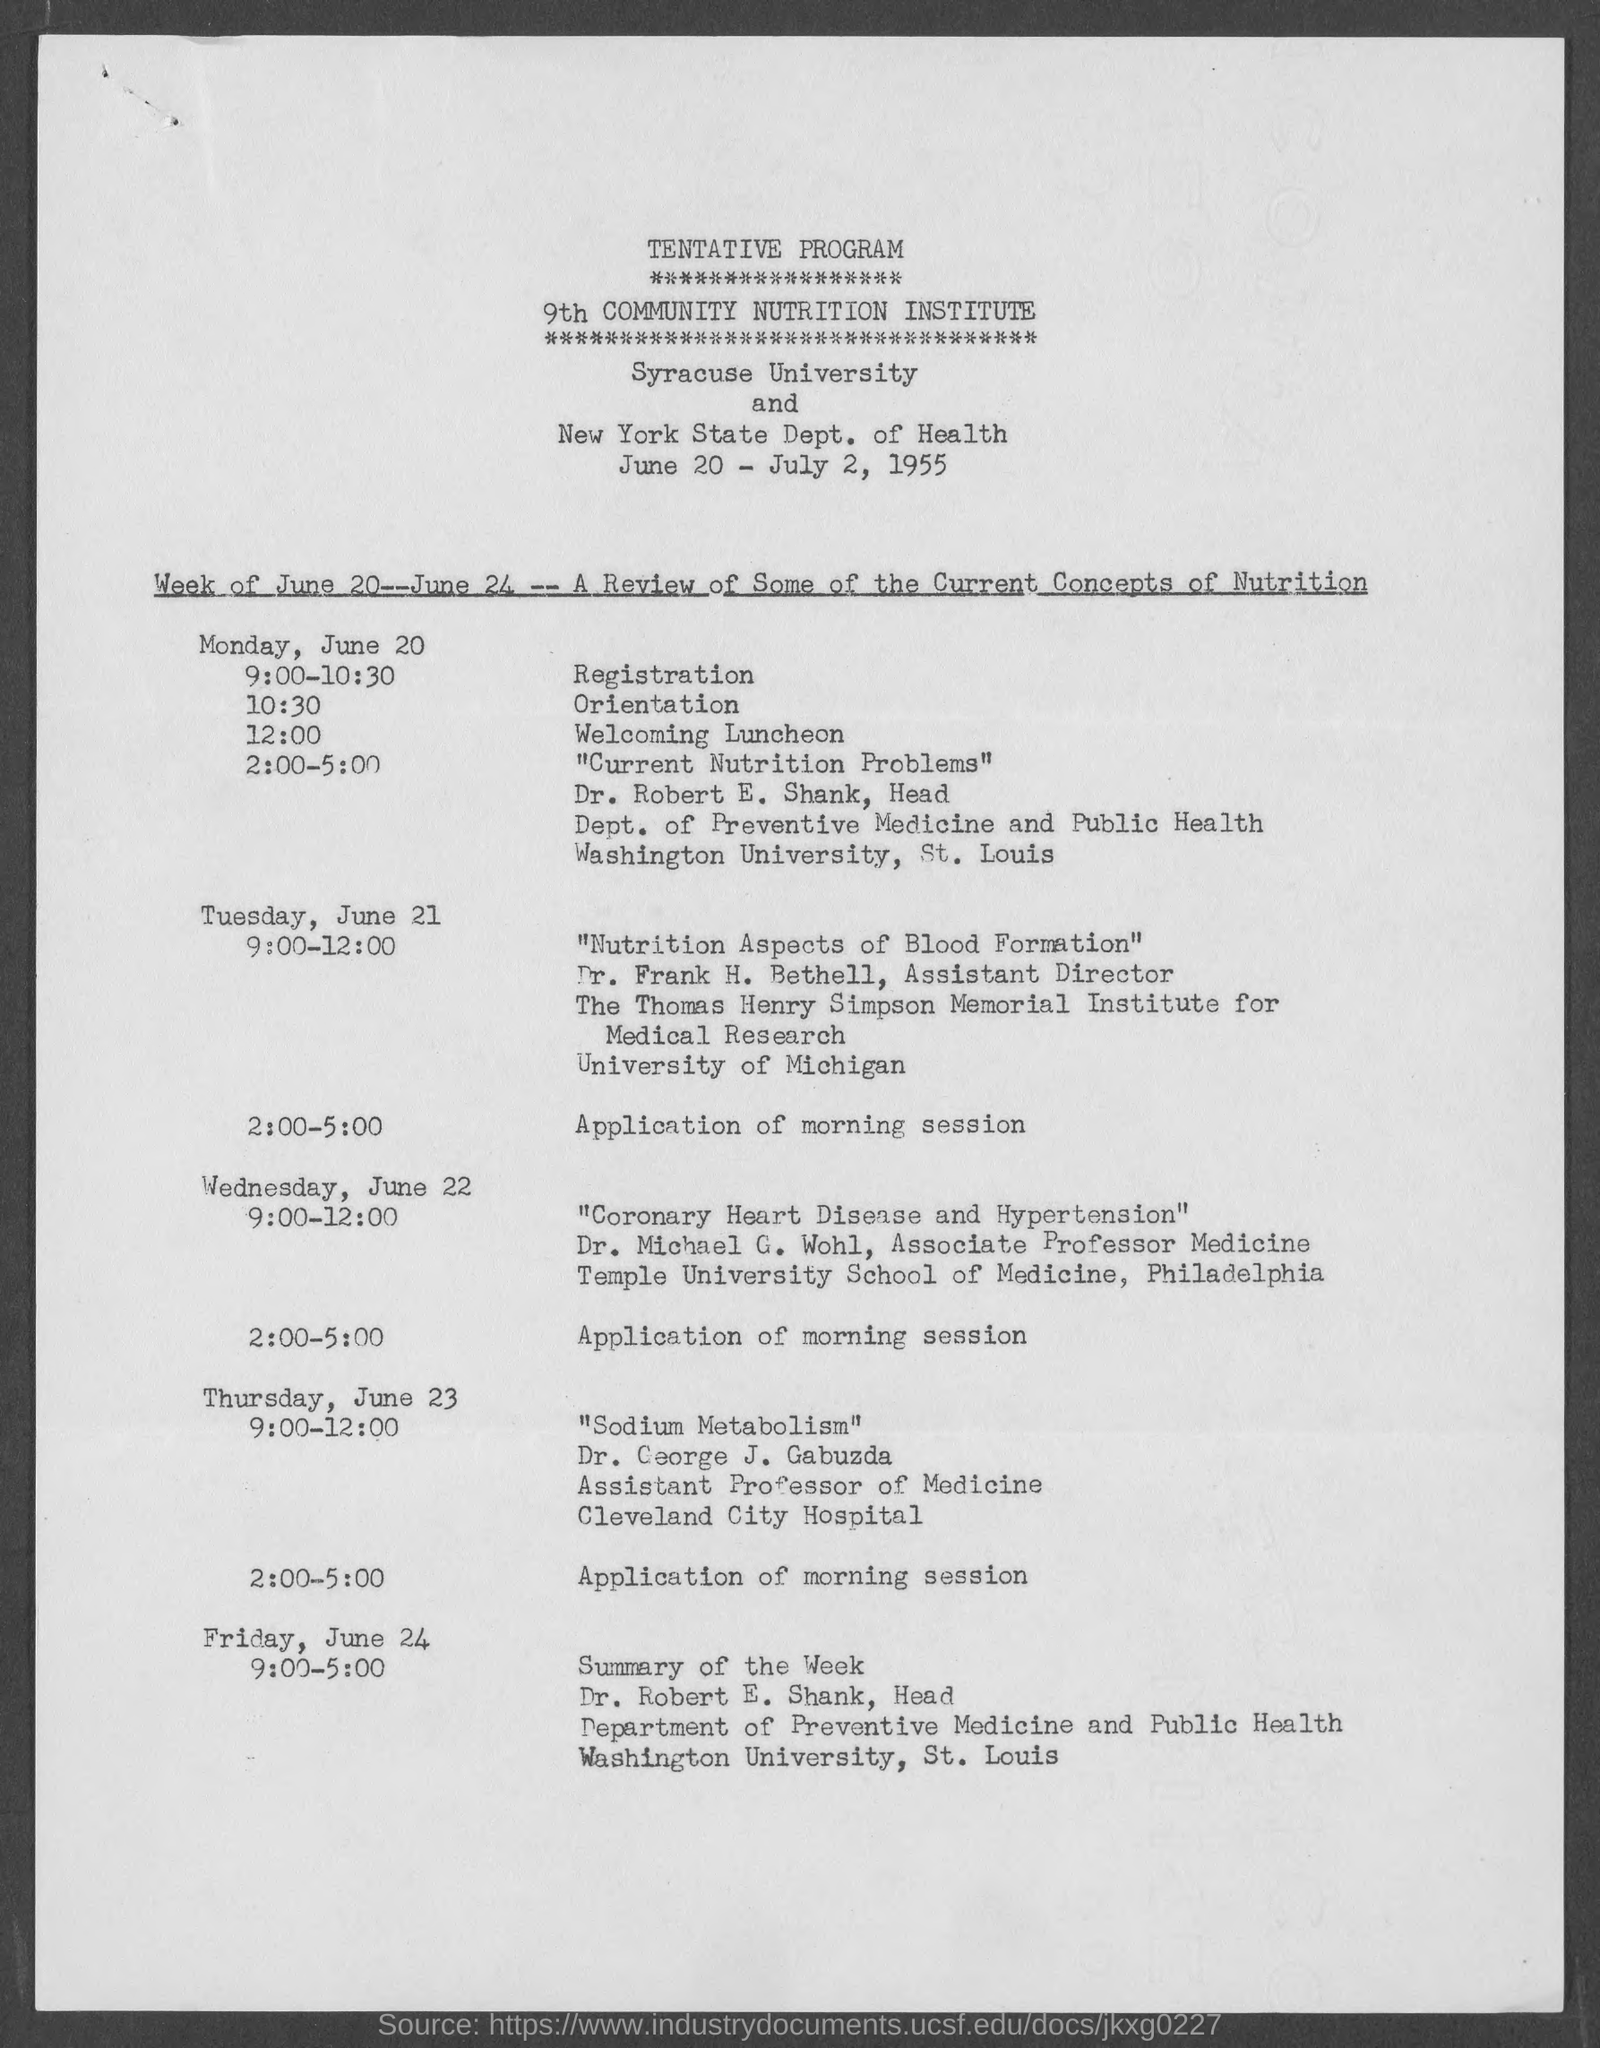What is the schedule at the time of 9:00 - 10:30 on monday , june 20 ?
Provide a short and direct response. REGISTRATION. What is the given schedule at the time of 10:30 on monday, june 20 ?
Make the answer very short. ORIENTATION. What is the given schedule at the time of 12:00 on monday , june 20 ?
Your answer should be compact. Welcoming luncheon. What is the given schedule at the time of 2:00 - 5:00 on tuesday , june 21 ?
Offer a terse response. Application of morning session. To which dept. dr. robert e. shank belongs to ?
Your answer should be compact. Dept. of preventive medicine and public health. What is the designation of dr. frank h. bethell ?
Provide a short and direct response. ASSISTANT DIRECTOR. What is the given schedule at the time of 9:00 - 5:00 on friday, june 24 ?
Your answer should be compact. SUMMARY OF THE WEEK. 